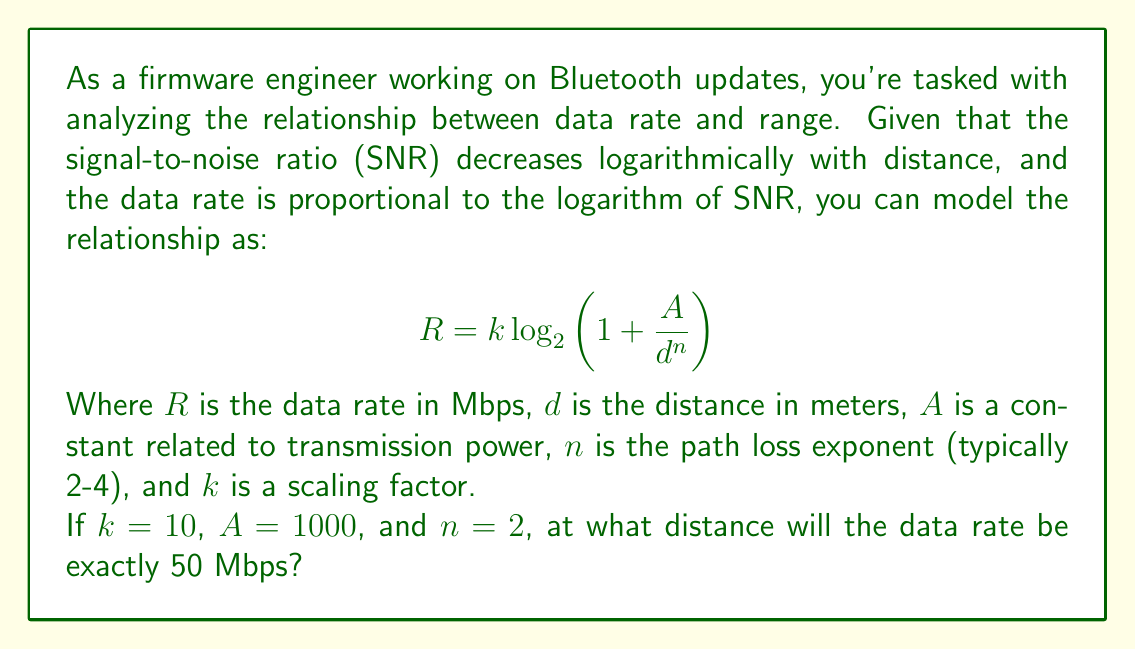Could you help me with this problem? Let's approach this step-by-step:

1) We're given the equation: $R = k \log_2(1 + \frac{A}{d^n})$

2) We know:
   $R = 50$ Mbps
   $k = 10$
   $A = 1000$
   $n = 2$

3) Let's substitute these values into the equation:

   $$ 50 = 10 \log_2(1 + \frac{1000}{d^2}) $$

4) Divide both sides by 10:

   $$ 5 = \log_2(1 + \frac{1000}{d^2}) $$

5) Apply $2^x$ to both sides:

   $$ 2^5 = 1 + \frac{1000}{d^2} $$

6) Simplify:

   $$ 32 = 1 + \frac{1000}{d^2} $$

7) Subtract 1 from both sides:

   $$ 31 = \frac{1000}{d^2} $$

8) Multiply both sides by $d^2$:

   $$ 31d^2 = 1000 $$

9) Divide both sides by 31:

   $$ d^2 = \frac{1000}{31} $$

10) Take the square root of both sides:

    $$ d = \sqrt{\frac{1000}{31}} $$

11) Simplify:

    $$ d \approx 5.67 $$

Therefore, the data rate will be exactly 50 Mbps at a distance of approximately 5.67 meters.
Answer: $5.67$ meters 